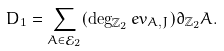Convert formula to latex. <formula><loc_0><loc_0><loc_500><loc_500>D _ { 1 } = \sum _ { A \in \mathcal { E } _ { 2 } } ( \deg _ { \mathbb { Z } _ { 2 } } e v _ { A , J } ) \partial _ { \mathbb { Z } _ { 2 } } A .</formula> 